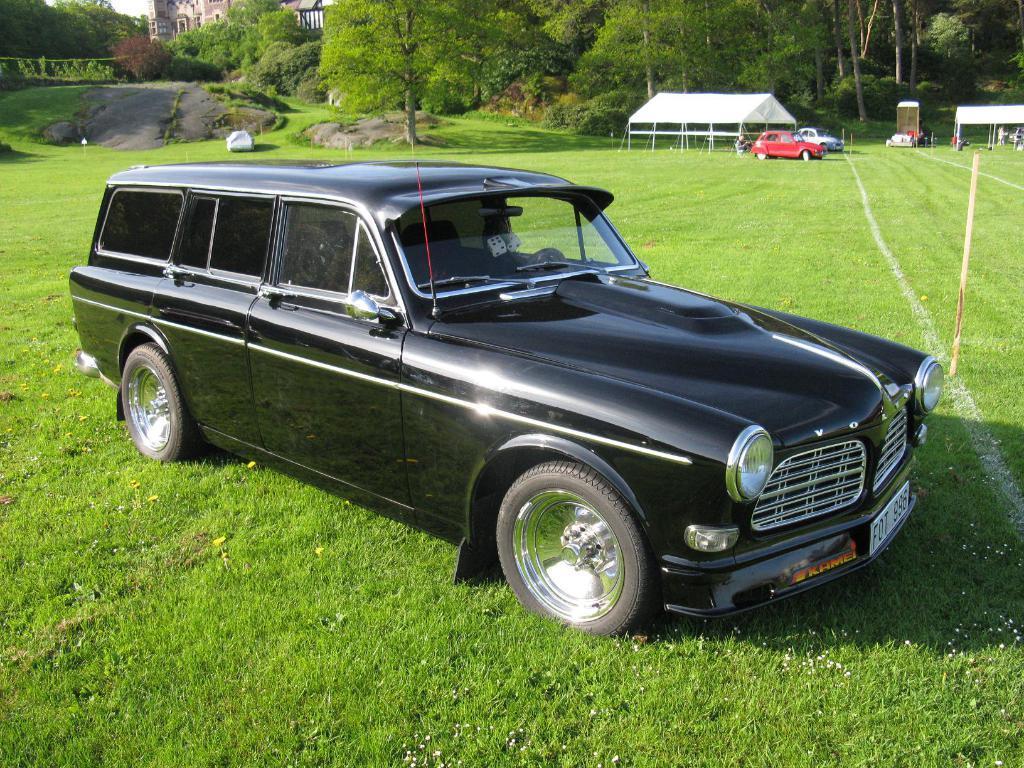Can you describe this image briefly? In this image we can see a car. On the ground there is grass. In the back there are cats, shed, trees, rocks and a building. 